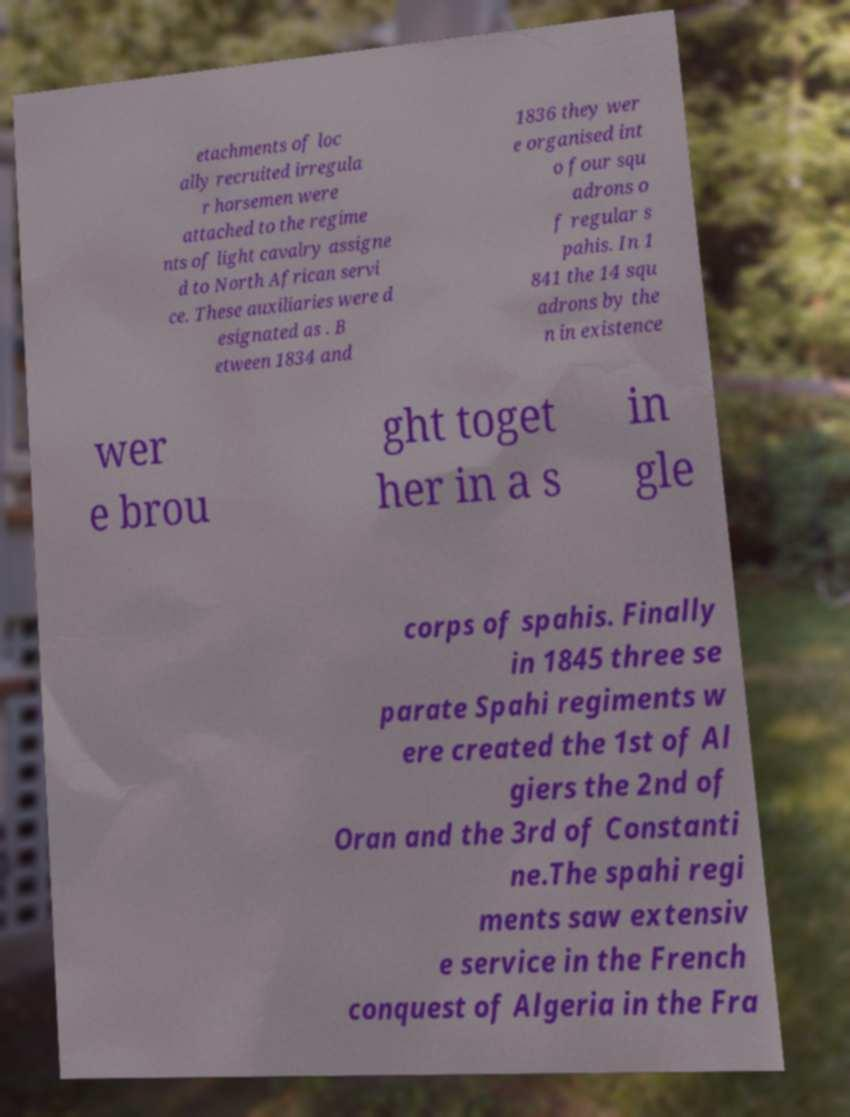Can you accurately transcribe the text from the provided image for me? etachments of loc ally recruited irregula r horsemen were attached to the regime nts of light cavalry assigne d to North African servi ce. These auxiliaries were d esignated as . B etween 1834 and 1836 they wer e organised int o four squ adrons o f regular s pahis. In 1 841 the 14 squ adrons by the n in existence wer e brou ght toget her in a s in gle corps of spahis. Finally in 1845 three se parate Spahi regiments w ere created the 1st of Al giers the 2nd of Oran and the 3rd of Constanti ne.The spahi regi ments saw extensiv e service in the French conquest of Algeria in the Fra 